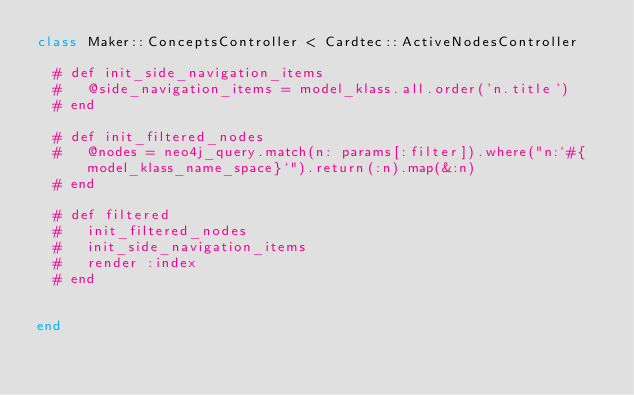Convert code to text. <code><loc_0><loc_0><loc_500><loc_500><_Ruby_>class Maker::ConceptsController < Cardtec::ActiveNodesController

  # def init_side_navigation_items
  #   @side_navigation_items = model_klass.all.order('n.title')
  # end

  # def init_filtered_nodes
  #   @nodes = neo4j_query.match(n: params[:filter]).where("n:`#{model_klass_name_space}`").return(:n).map(&:n)
  # end

  # def filtered
  #   init_filtered_nodes
  #   init_side_navigation_items
  #   render :index
  # end


end
</code> 